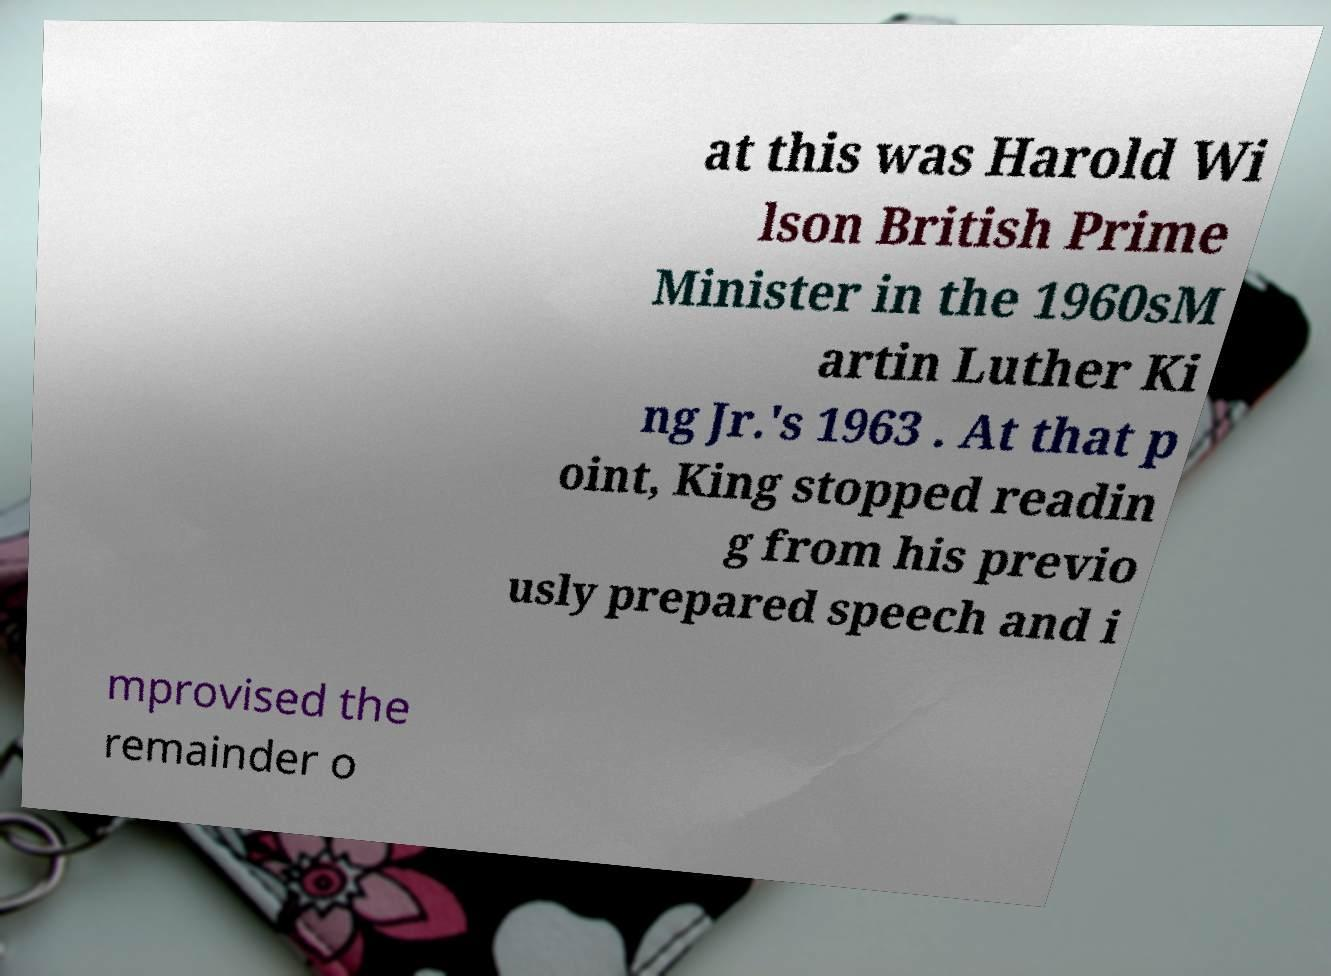Could you extract and type out the text from this image? at this was Harold Wi lson British Prime Minister in the 1960sM artin Luther Ki ng Jr.'s 1963 . At that p oint, King stopped readin g from his previo usly prepared speech and i mprovised the remainder o 